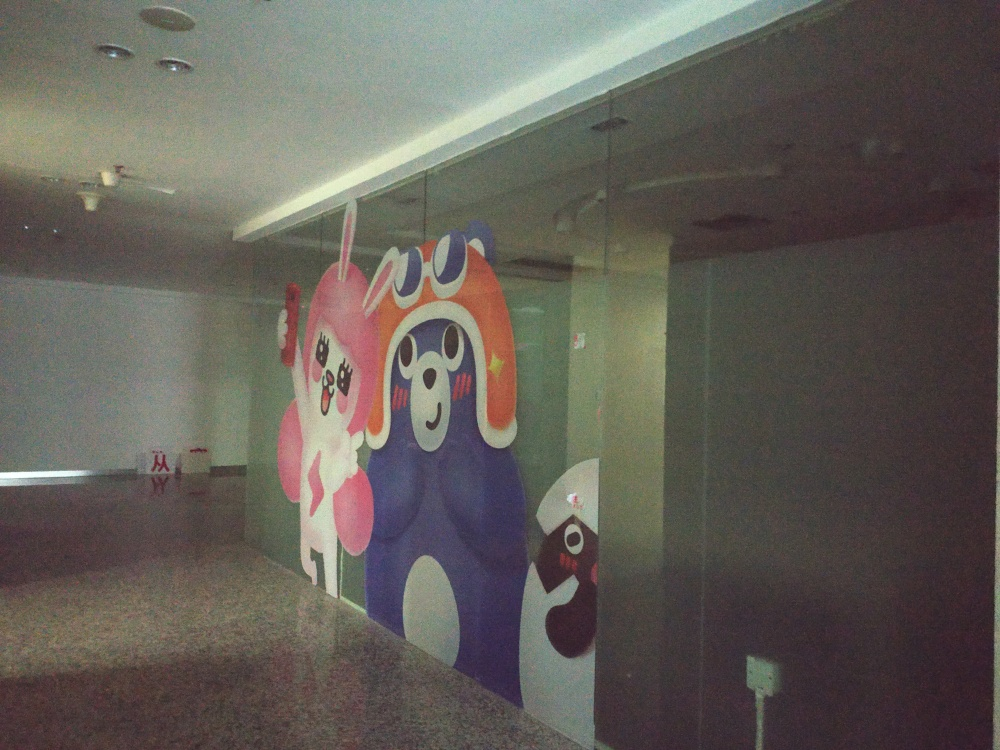What is the style of the artwork on the wall? The artwork on the wall appears to be in a playful and whimsical style, with cartoon-like characters that use bright colors and exaggerated features to convey a sense of fun and creativity. 